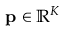Convert formula to latex. <formula><loc_0><loc_0><loc_500><loc_500>p \in \mathbb { R } ^ { K }</formula> 